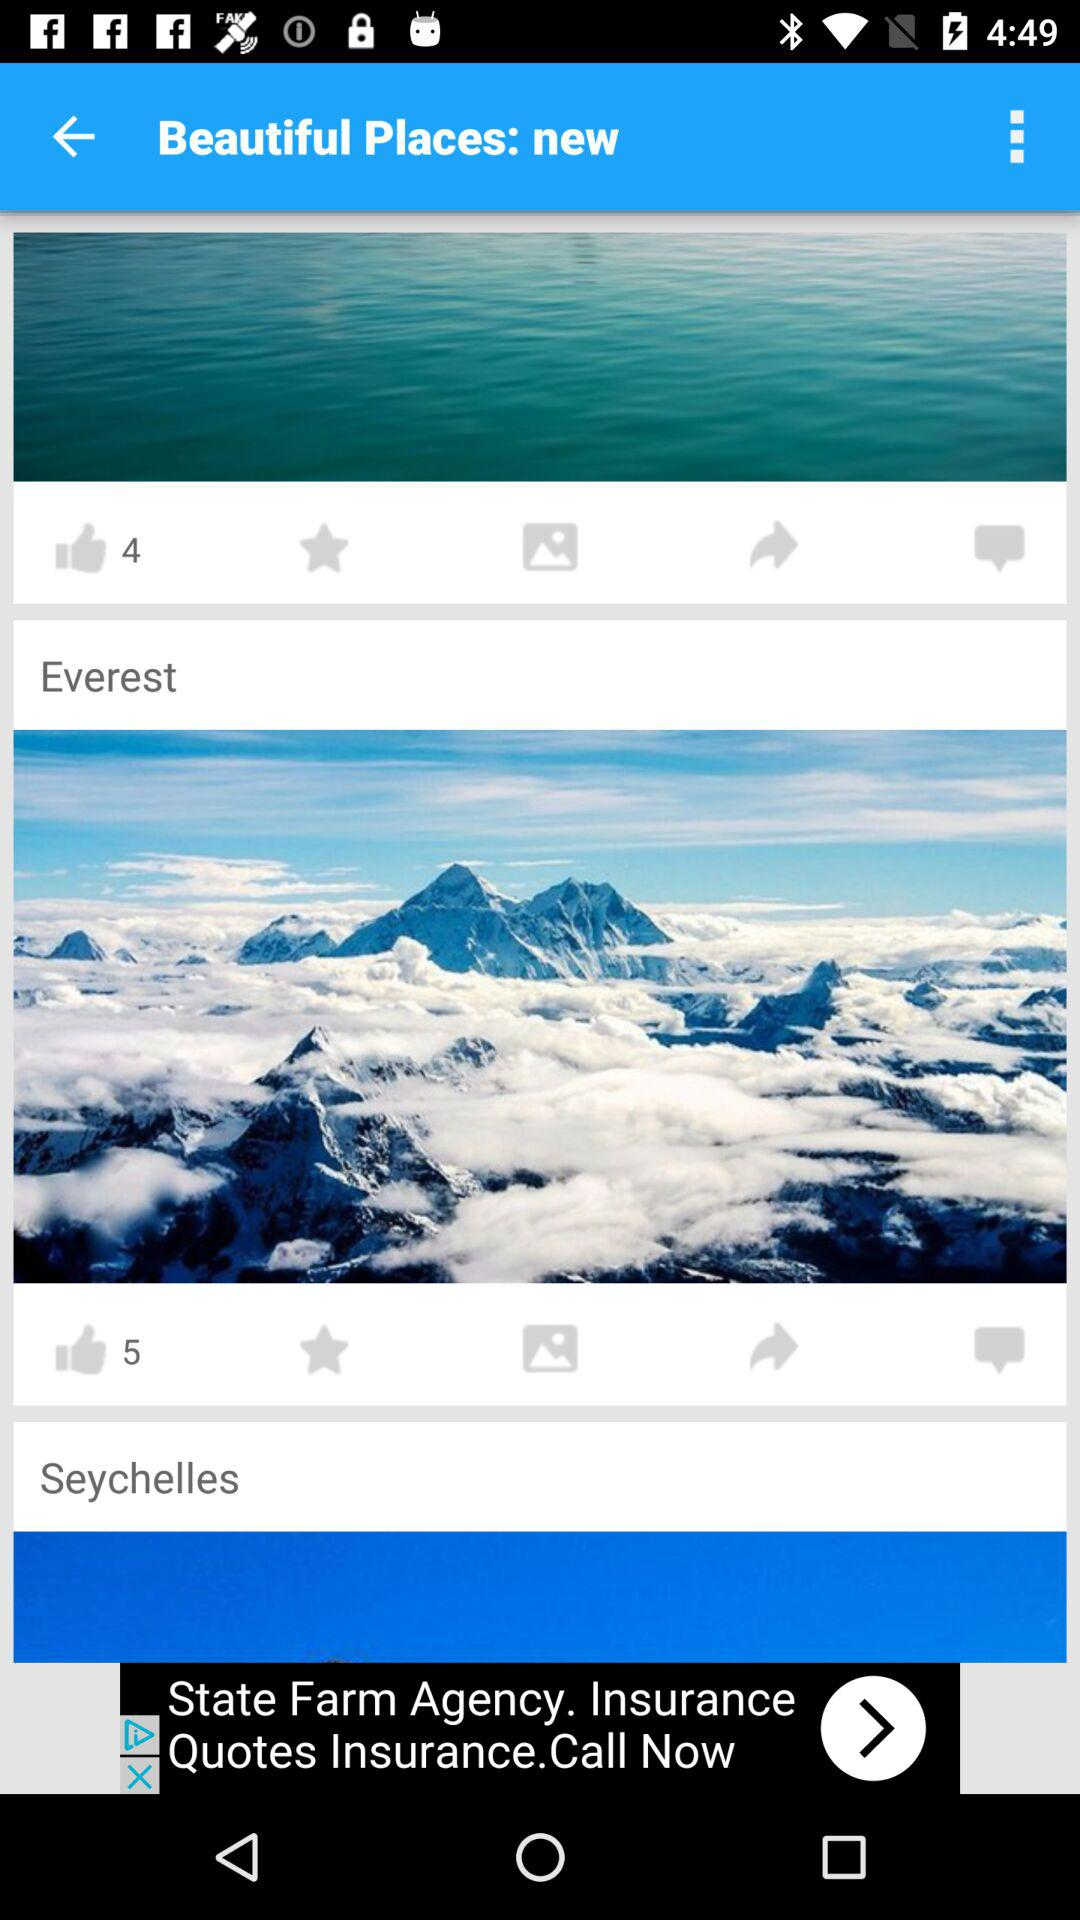Which are the beautiful places on the screen? The beautiful places are "Everest" and "Seychelles". 